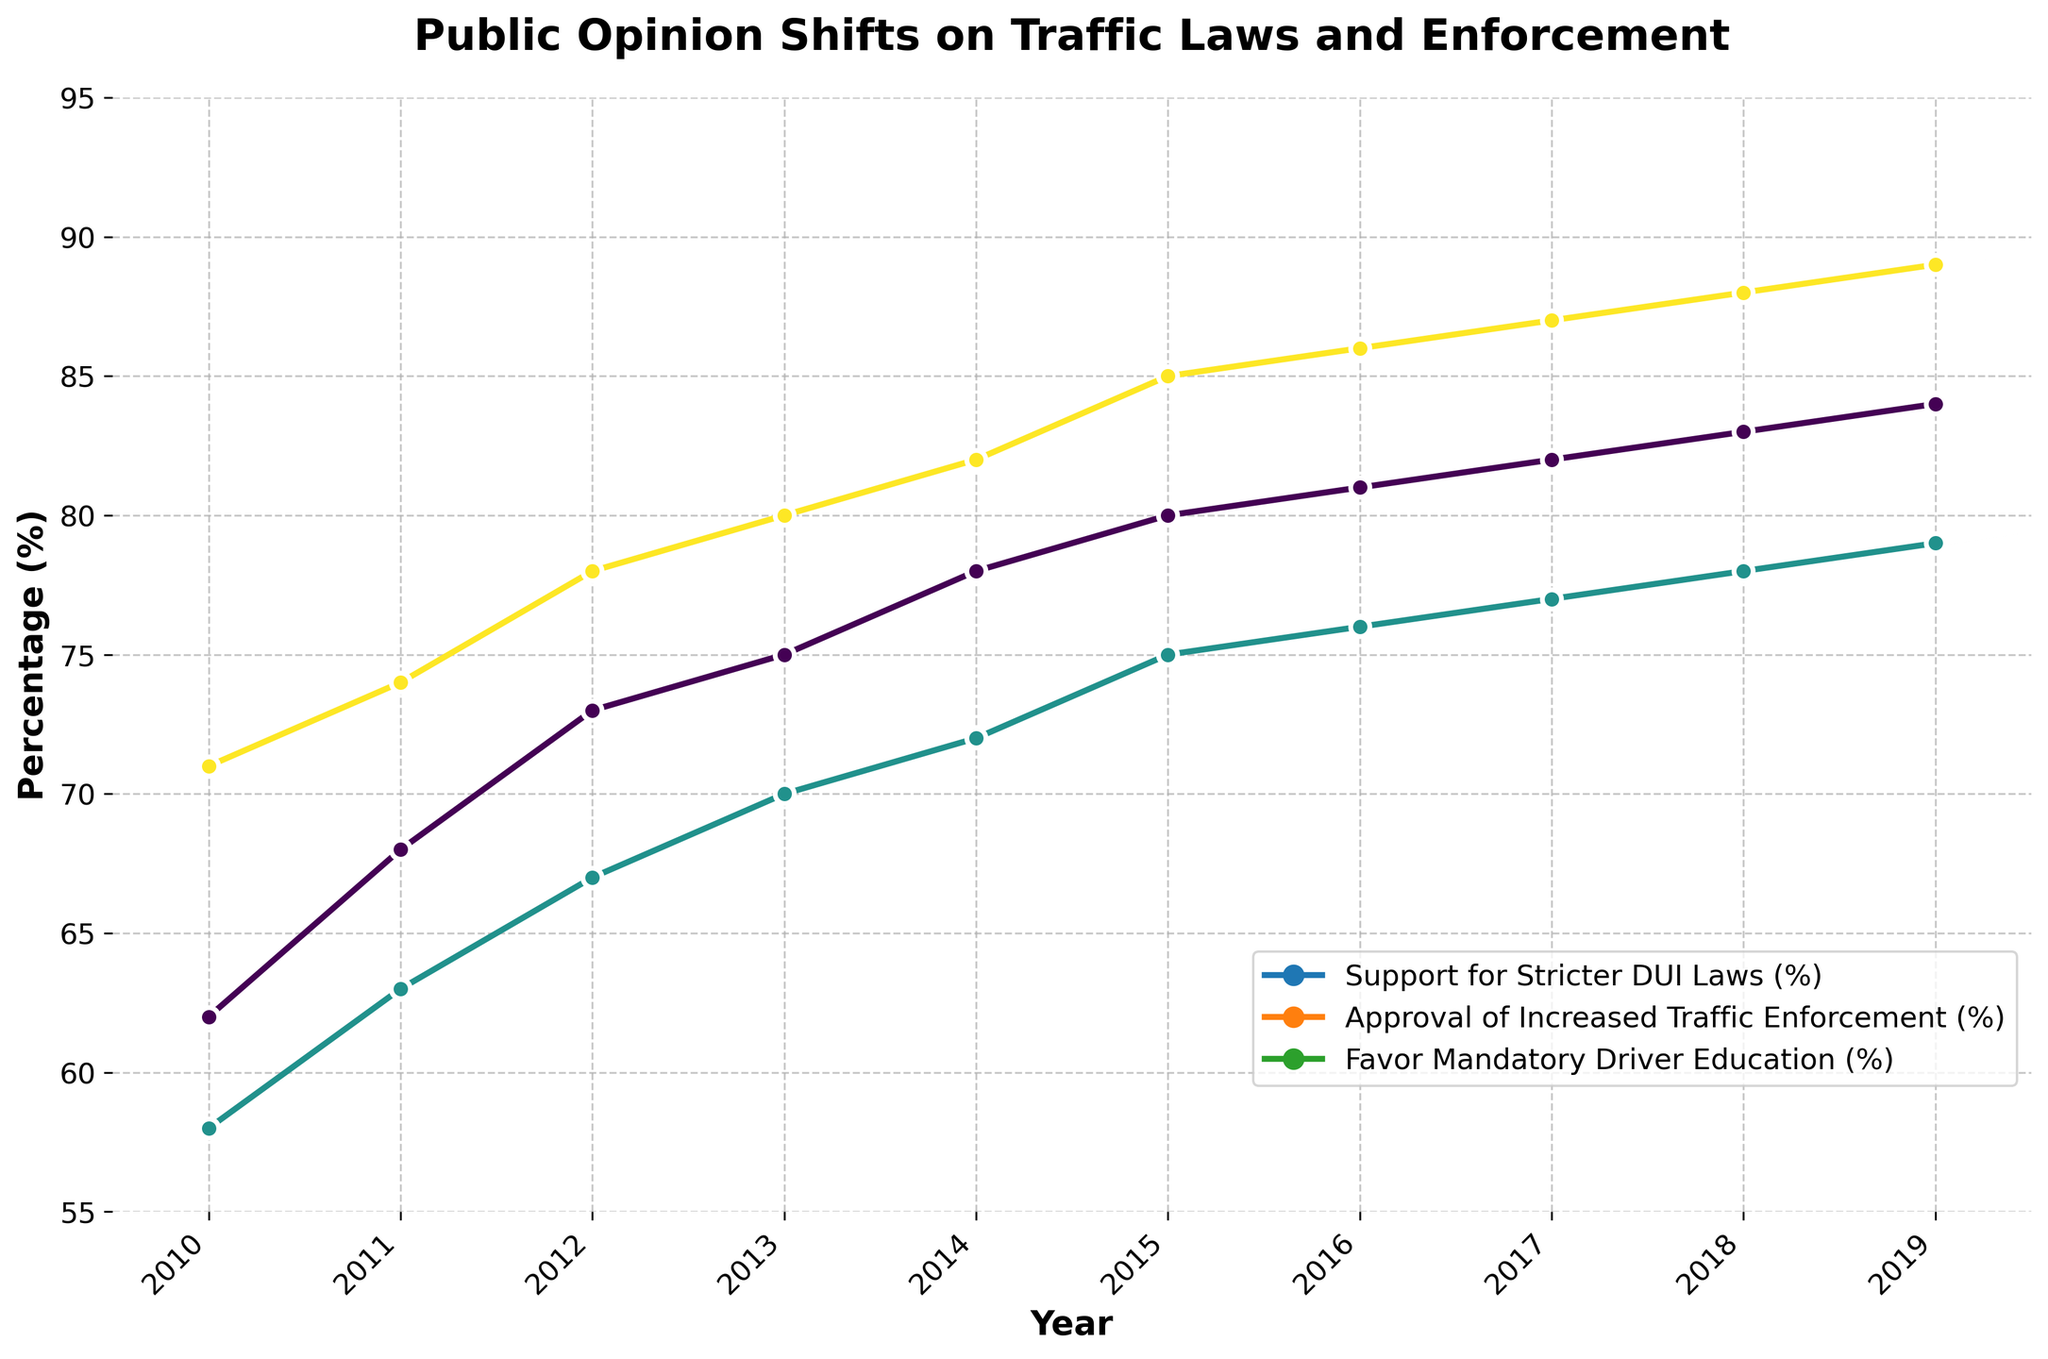What is the overall trend in public opinion regarding stricter DUI laws from 2010 to 2019? The general trend shows a consistent increase over the years. Starting from 62% in 2010, the support gradually increased every year, reaching 84% in 2019.
Answer: Consistent increase How does the approval of increased traffic enforcement in 2014 compare to 2015? The approval increased from 72% in 2014 to 75% in 2015. So, the difference is 75% - 72% = 3%.
Answer: 3% Which measure shows the highest percentage of public support in 2016? By comparing all the percentages for 2016, Mandatory Driver Education has the highest support at 86%.
Answer: Mandatory Driver Education Which year's data shows the smallest difference between support for DUI laws and approval of increased traffic enforcement? Calculate the differences for each year: 
2010: 62-58=4, 
2011: 68-63=5, 
2012: 73-67=6, 
2013: 75-70=5, 
2014: 78-72=6, 
2015: 80-75=5, 
2016: 81-76=5,
2017: 82-77=5, 
2018: 83-78=5, 
2019: 84-79=5.
The smallest difference is 4 in the year 2010.
Answer: 2010 What is the average support for stricter DUI laws over the 10-year period? Add the support percentages from 2010 to 2019 and then divide by 10: 
(62 + 68 + 73 + 75 + 78 + 80 + 81 + 82 + 83 + 84) / 10 = 74.6%.
Answer: 74.6% Did the favor for mandatory driver education ever decrease during this time period? By visually checking the trend line for Mandatory Driver Education, it consistently increases from 71% in 2010 to 89% in 2019 with no decreases.
Answer: No What is the total increase in approval of increased traffic enforcement from 2010 to 2019? The approval increased from 58% in 2010 to 79% in 2019. So, the total increase is 79% - 58% = 21%.
Answer: 21% During which years did the support for stricter DUI laws see the largest yearly increase? Calculate the yearly increases: 
2011: 68-62=6, 
2012: 73-68=5, 
2013: 75-73=2, 
2014: 78-75=3, 
2015: 80-78=2, 
2016: 81-80=1,
2017: 82-81=1, 
2018: 83-82=1, 
2019: 84-83=1.
The largest yearly increase is 6% from 2010 to 2011.
Answer: 2010 to 2011 Which opinion measure reached 80% support first, and in which year? By checking the plotted lines, Mandatory Driver Education reached 80% support first in 2013.
Answer: Mandatory Driver Education in 2013 